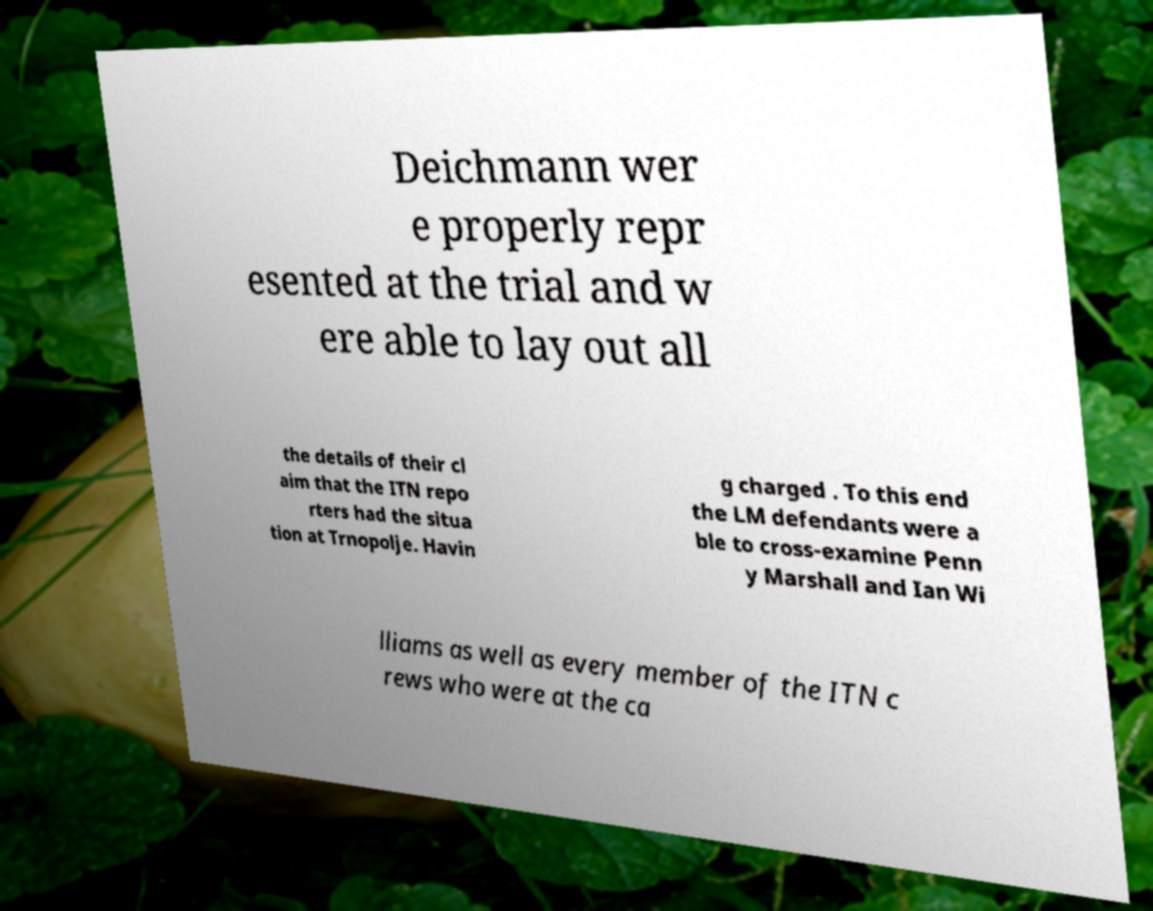For documentation purposes, I need the text within this image transcribed. Could you provide that? Deichmann wer e properly repr esented at the trial and w ere able to lay out all the details of their cl aim that the ITN repo rters had the situa tion at Trnopolje. Havin g charged . To this end the LM defendants were a ble to cross-examine Penn y Marshall and Ian Wi lliams as well as every member of the ITN c rews who were at the ca 